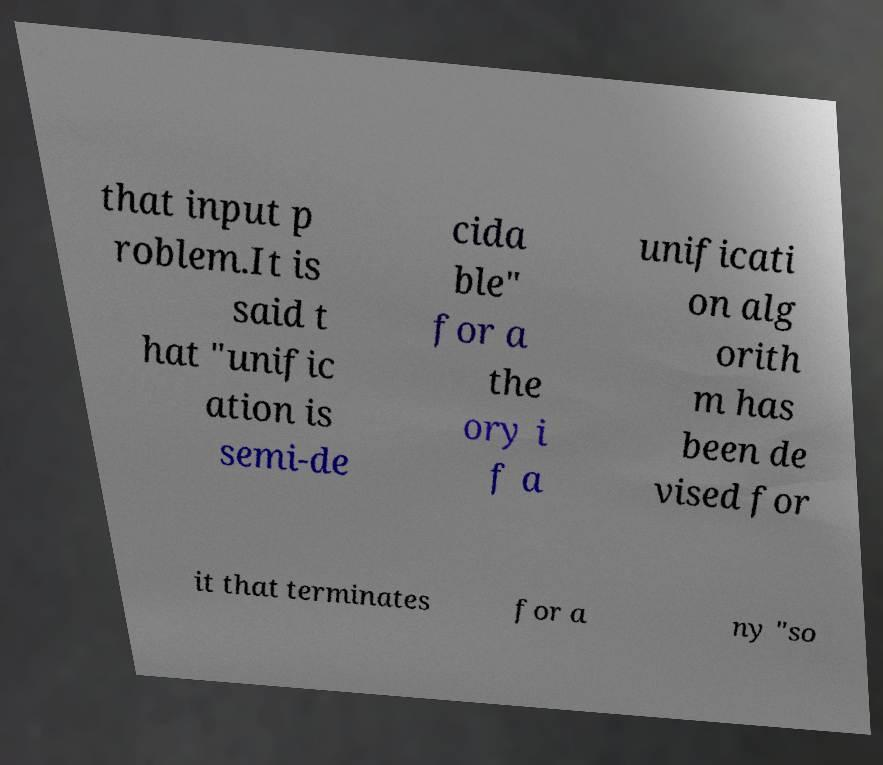Please read and relay the text visible in this image. What does it say? that input p roblem.It is said t hat "unific ation is semi-de cida ble" for a the ory i f a unificati on alg orith m has been de vised for it that terminates for a ny "so 